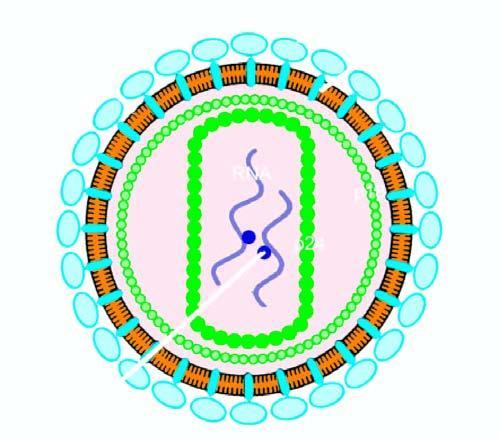how many strands does the particle have?
Answer the question using a single word or phrase. Two 